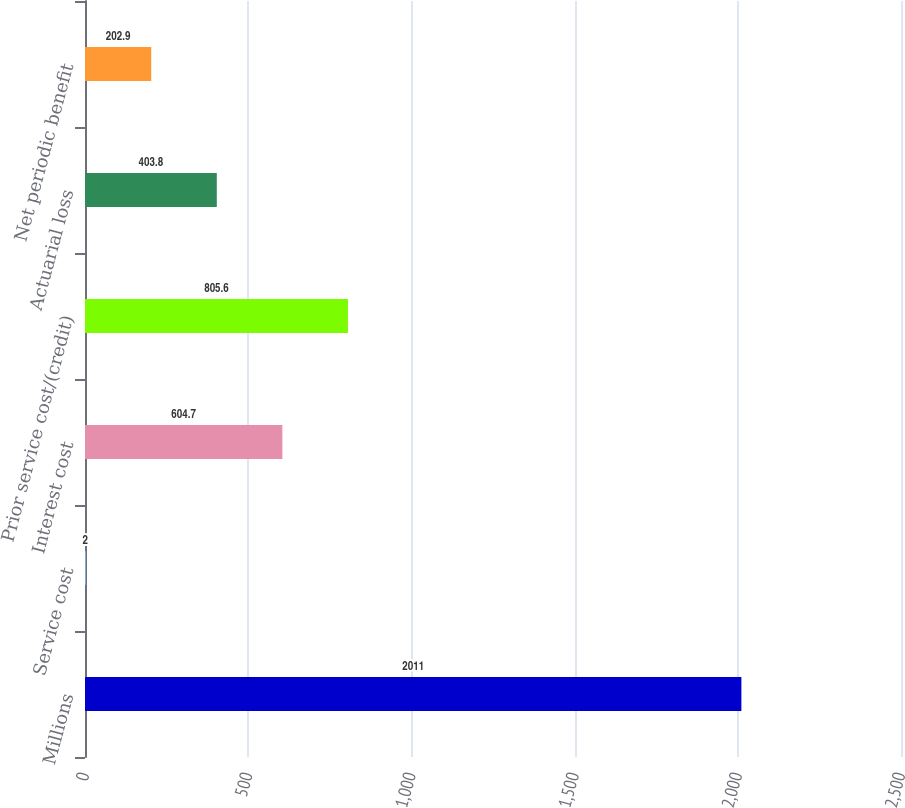Convert chart. <chart><loc_0><loc_0><loc_500><loc_500><bar_chart><fcel>Millions<fcel>Service cost<fcel>Interest cost<fcel>Prior service cost/(credit)<fcel>Actuarial loss<fcel>Net periodic benefit<nl><fcel>2011<fcel>2<fcel>604.7<fcel>805.6<fcel>403.8<fcel>202.9<nl></chart> 